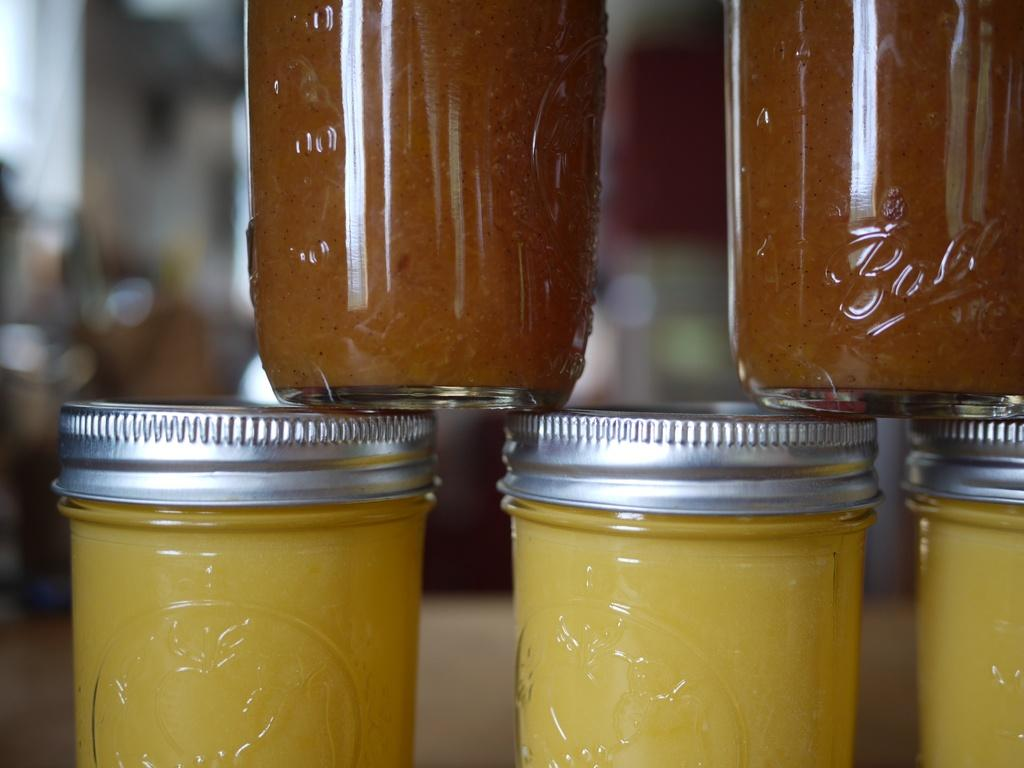How many glass jars are visible in the image? There are 5 glass jars in the image. What is the appearance of the lids on the jars? Each jar has a silver lid. Can you describe the background of the image? The background of the image is blurred. How many cakes are sitting on top of the glass jars in the image? There are no cakes present in the image; it only features glass jars with silver lids. 